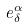<formula> <loc_0><loc_0><loc_500><loc_500>e _ { \delta } ^ { \alpha }</formula> 